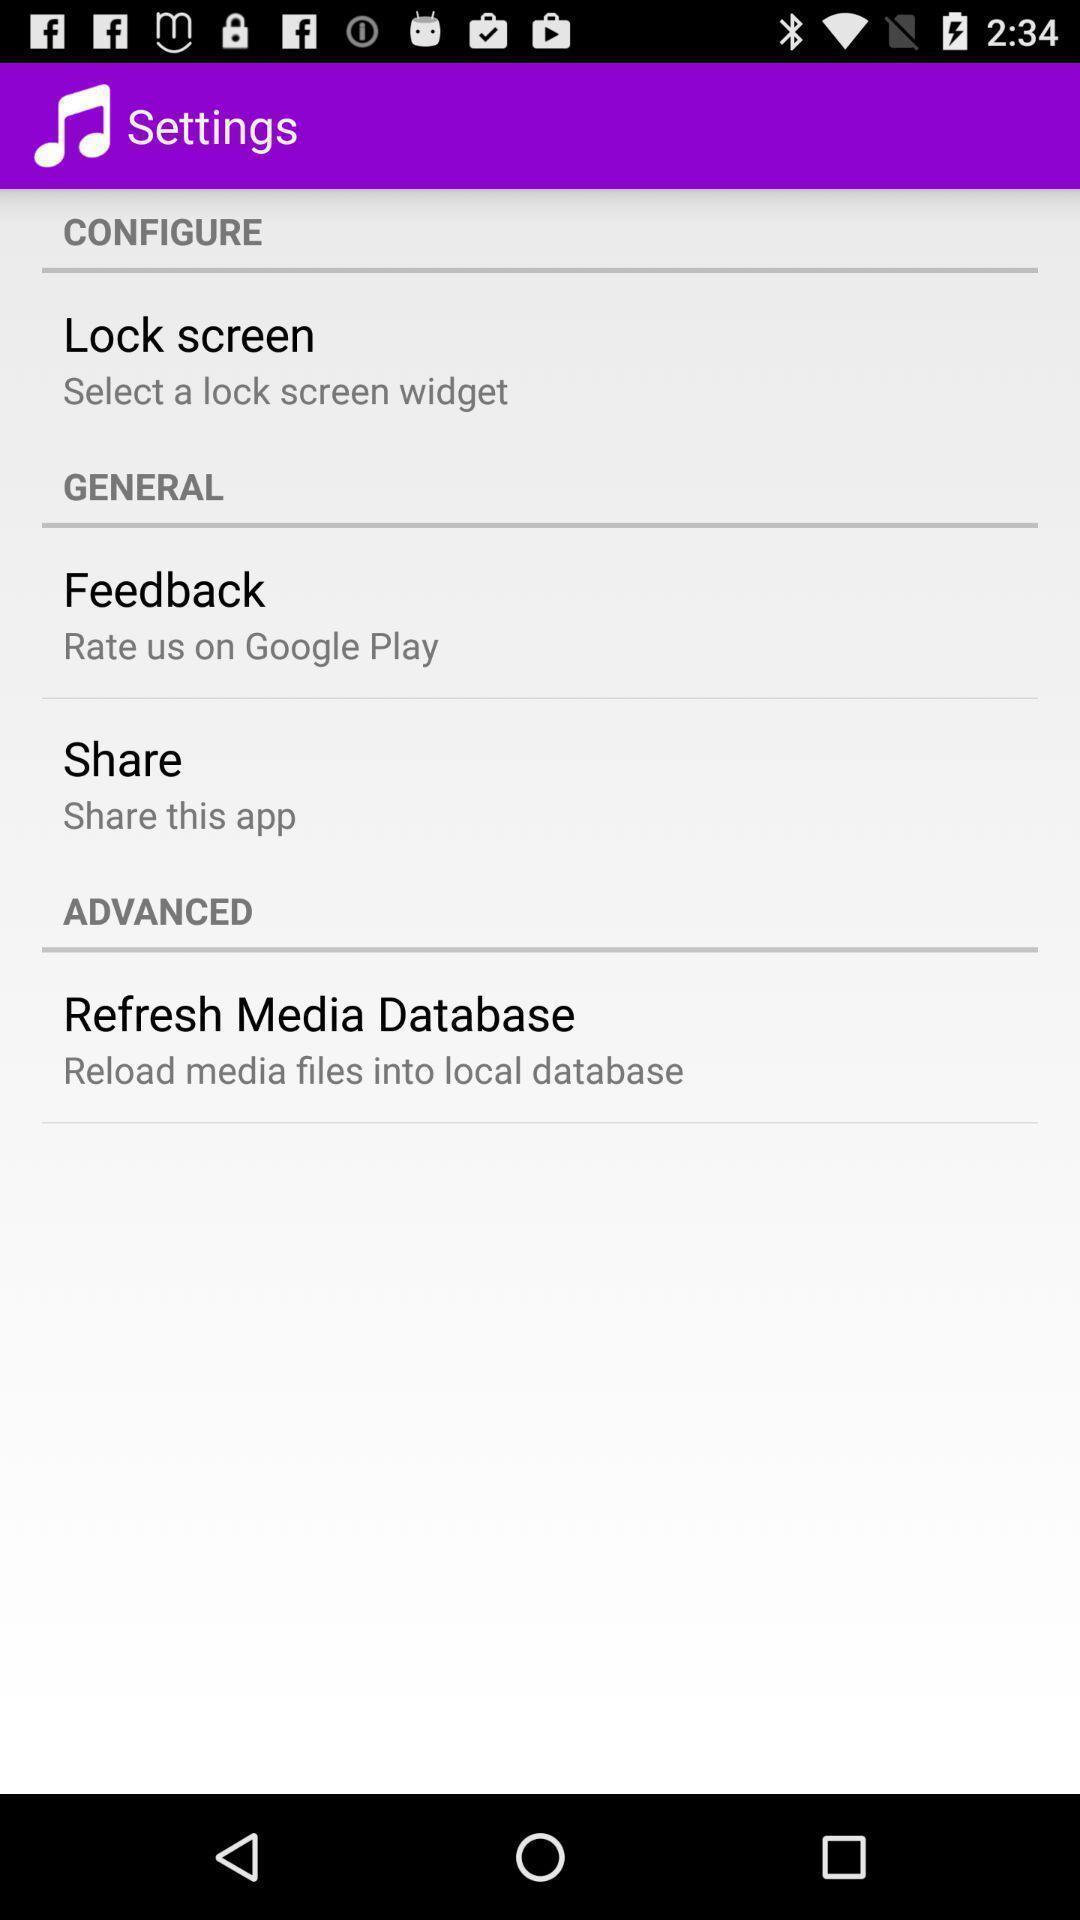Explain the elements present in this screenshot. Settings page. 